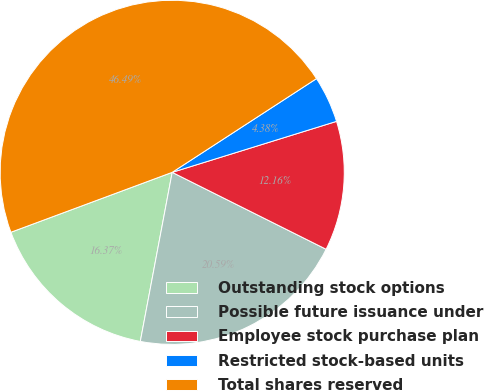Convert chart to OTSL. <chart><loc_0><loc_0><loc_500><loc_500><pie_chart><fcel>Outstanding stock options<fcel>Possible future issuance under<fcel>Employee stock purchase plan<fcel>Restricted stock-based units<fcel>Total shares reserved<nl><fcel>16.37%<fcel>20.59%<fcel>12.16%<fcel>4.38%<fcel>46.49%<nl></chart> 